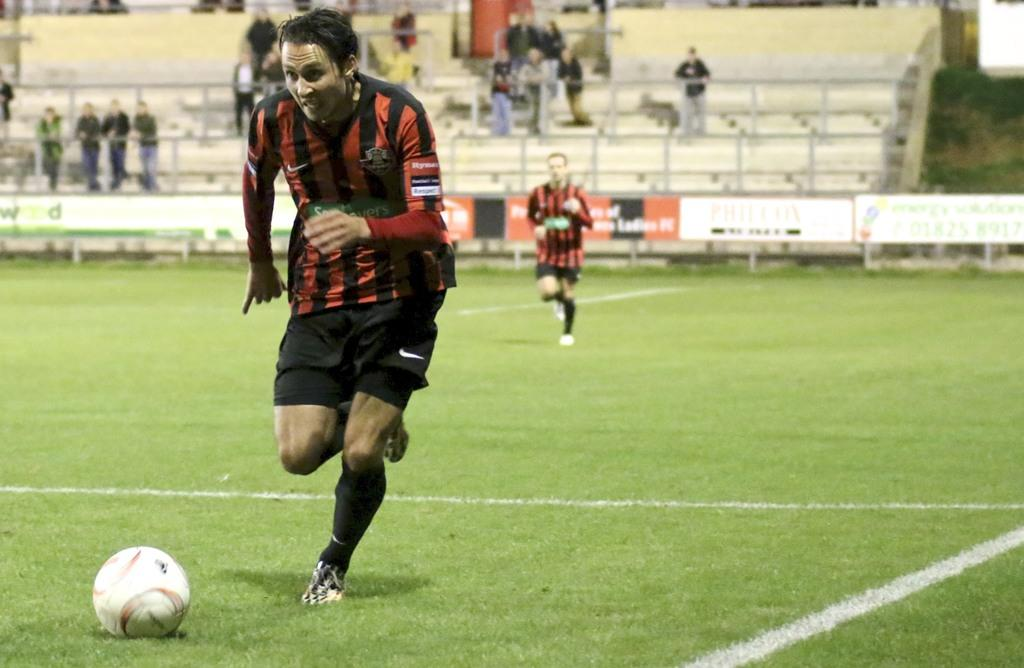What are the two men in the image doing? The two men in the image are running. On what surface are the men running? The men are running on the ground. What is present on the ground in the image? There is a ball on the ground. What can be seen in the background of the image? There is a fence, grass, and other people in the background of the image. What type of blade is being used by the men in the image? There is no blade visible in the image; the men are running without any apparent tools or equipment. 